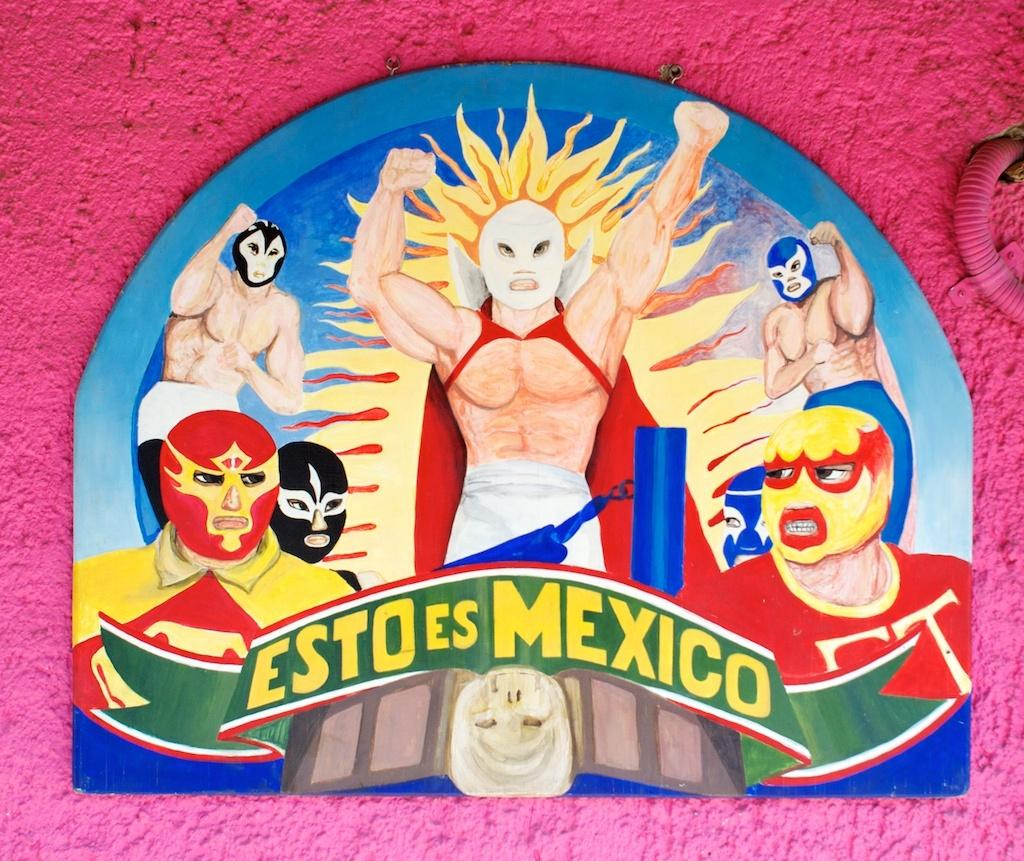What can be seen in the image? There are depictions of persons in the image. What is the color of the wall in the background? There is a pink wall in the background of the image. What time is displayed on the clocks in the image? There are no clocks present in the image, so it is not possible to determine the time displayed. 